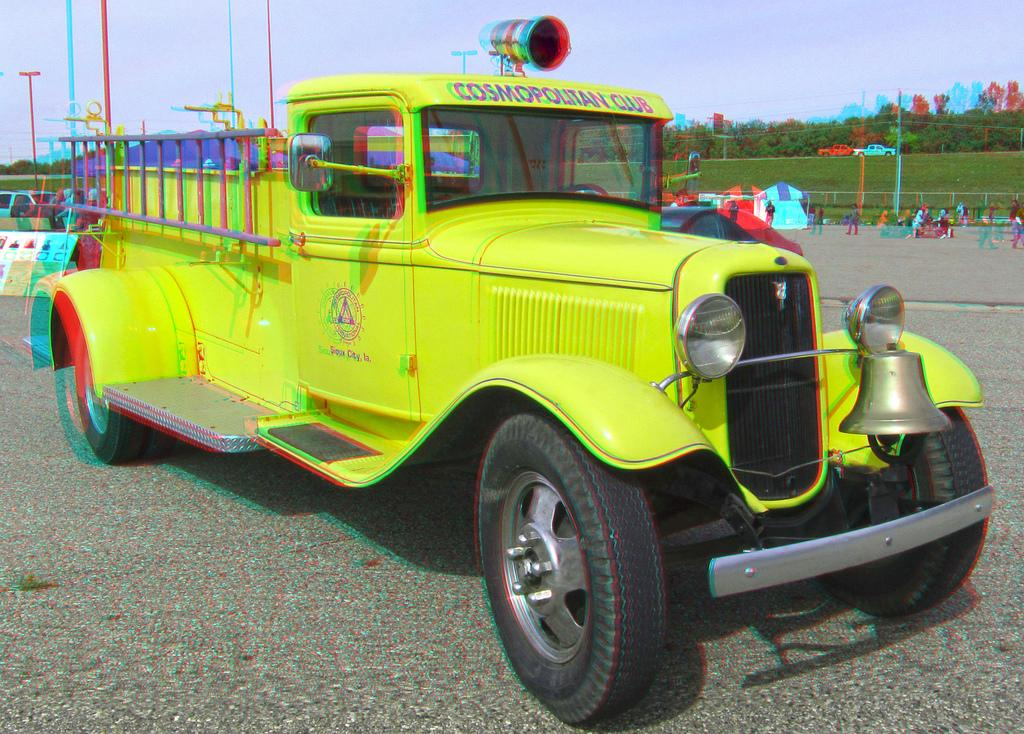What color is the vehicle in the image? The vehicle in the image is green. What feature does the vehicle have that allows it to move? The vehicle has wheels. Where is the vehicle located in the image? The vehicle is on a surface. What type of glue is being used to hold the dolls together in the image? There are no dolls present in the image, so there is no glue or dolls to discuss. What type of jail can be seen in the image? There is no jail present in the image. 